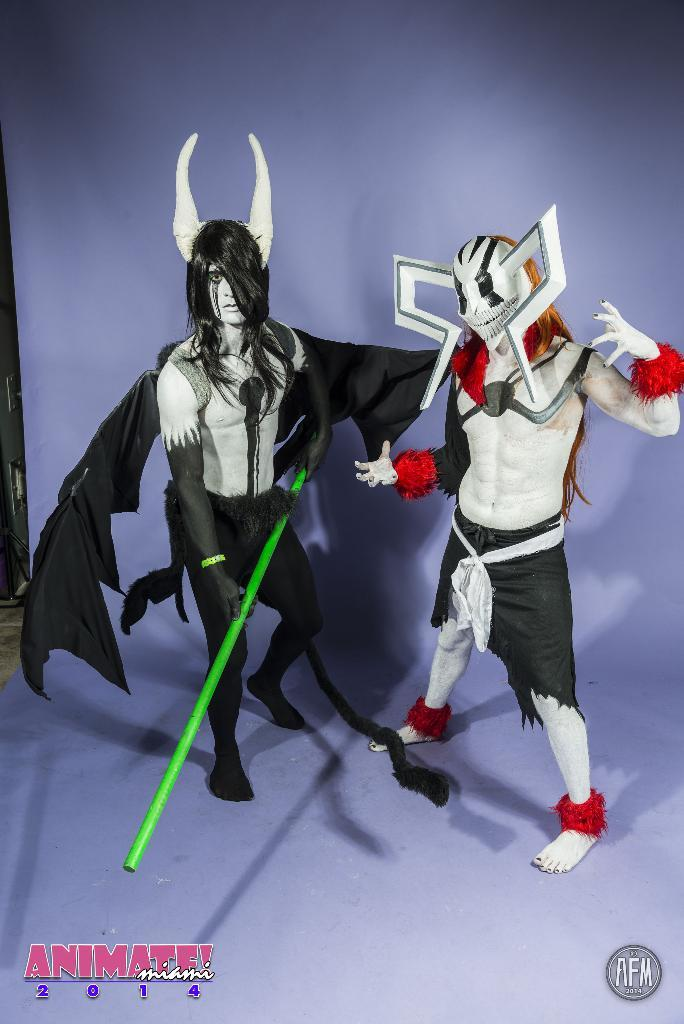How many people are in the image? There are two people in the image. What are the people wearing? The two people are wearing different costumes. What are the people doing in the image? The two people are standing. What type of birds can be seen flying in the aftermath of the image? There are no birds or any indication of an aftermath in the image; it features two people wearing different costumes and standing. 